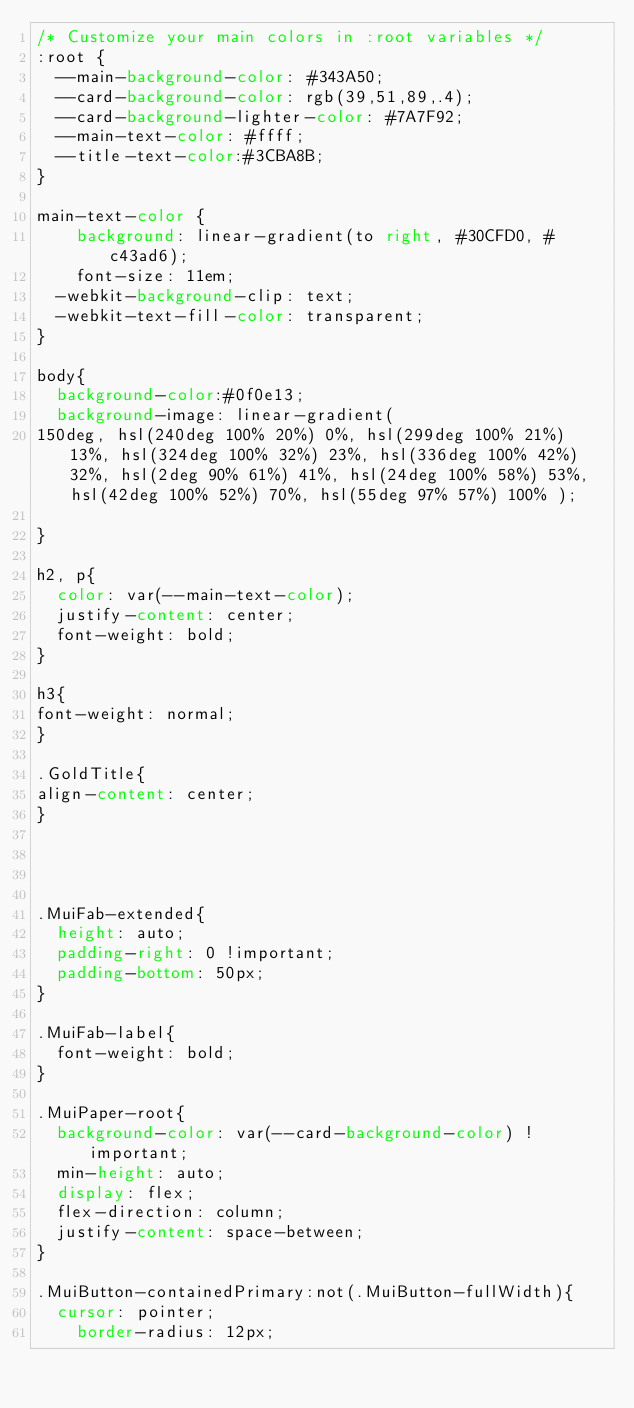Convert code to text. <code><loc_0><loc_0><loc_500><loc_500><_CSS_>/* Customize your main colors in :root variables */
:root {
  --main-background-color: #343A50;
  --card-background-color: rgb(39,51,89,.4);
  --card-background-lighter-color: #7A7F92;
  --main-text-color: #ffff;
  --title-text-color:#3CBA8B;
}

main-text-color {
    background: linear-gradient(to right, #30CFD0, #c43ad6);
    font-size: 11em;
  -webkit-background-clip: text;
  -webkit-text-fill-color: transparent;
}

body{
  background-color:#0f0e13;
  background-image: linear-gradient( 
150deg, hsl(240deg 100% 20%) 0%, hsl(299deg 100% 21%) 13%, hsl(324deg 100% 32%) 23%, hsl(336deg 100% 42%) 32%, hsl(2deg 90% 61%) 41%, hsl(24deg 100% 58%) 53%, hsl(42deg 100% 52%) 70%, hsl(55deg 97% 57%) 100% );
    
}

h2, p{
  color: var(--main-text-color);
  justify-content: center;
  font-weight: bold;
}

h3{
font-weight: normal;
}

.GoldTitle{
align-content: center;
}




.MuiFab-extended{
  height: auto;
  padding-right: 0 !important;
  padding-bottom: 50px;
}

.MuiFab-label{
  font-weight: bold;
}

.MuiPaper-root{
  background-color: var(--card-background-color) !important;
  min-height: auto;
  display: flex;
  flex-direction: column;
  justify-content: space-between;
}

.MuiButton-containedPrimary:not(.MuiButton-fullWidth){
  cursor: pointer;
    border-radius: 12px;</code> 